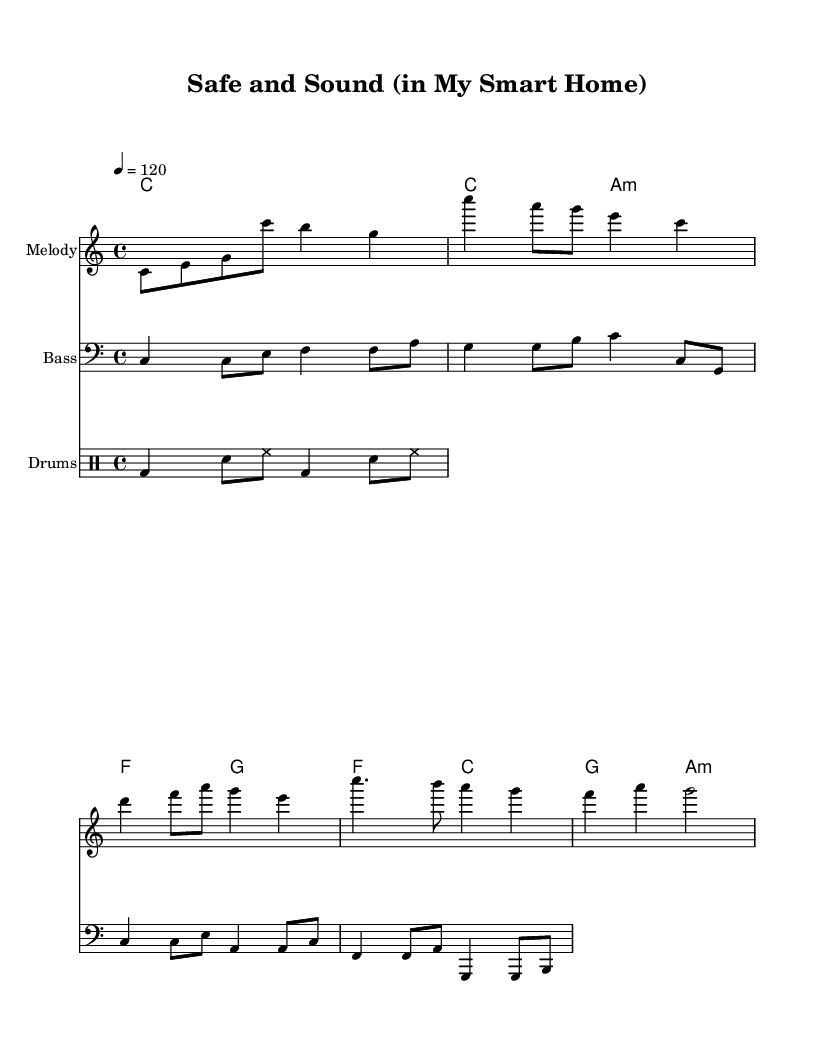What is the key signature of this music? The key signature is C major, which is indicated by the absence of sharps or flats in the key signature notation.
Answer: C major What is the time signature of this music? The time signature is 4/4, which means there are four beats in each measure, and each beat is a quarter note. This can be inferred from the notation at the beginning of the score.
Answer: 4/4 What is the tempo indication in this music? The tempo indication is marked as "4 = 120," which means there are 120 beats per minute, allowing the performers to maintain a steady pace.
Answer: 120 How many measures are in the verse? The verse section consists of 4 measures as seen in the notation, with each measure being represented in the melody and harmonies parts.
Answer: 4 What type of chord is used in the second measure of the verse? The chord used in the second measure of the verse is A minor, which can be identified by the "a:m" notation in the harmonies section, indicating it’s a minor chord.
Answer: A minor What instruments are notated in this score? The instruments notated in the score include Melody, Bass, and Drums, as indicated by the instrument names above each staff.
Answer: Melody, Bass, Drums What lyrical theme does this song celebrate? The lyrical theme celebrates technological advancements in home security, as evidenced by the lyrics that mention smart locks and motion sensors.
Answer: Technological advancements in home security 